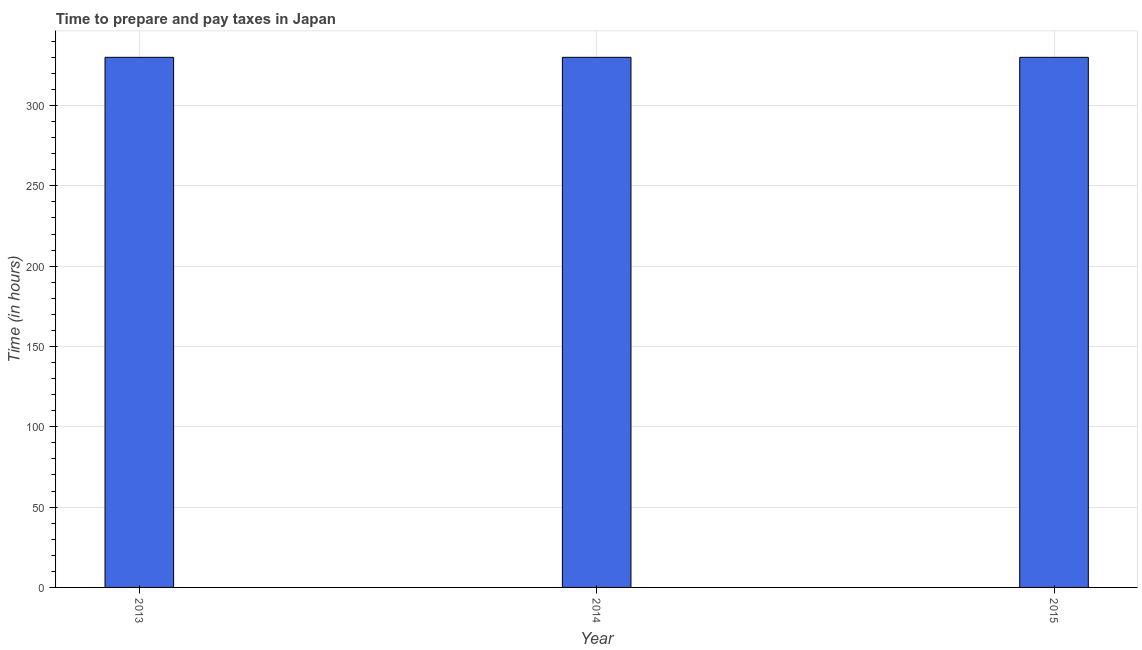Does the graph contain any zero values?
Keep it short and to the point. No. What is the title of the graph?
Offer a very short reply. Time to prepare and pay taxes in Japan. What is the label or title of the X-axis?
Offer a very short reply. Year. What is the label or title of the Y-axis?
Your answer should be very brief. Time (in hours). What is the time to prepare and pay taxes in 2014?
Give a very brief answer. 330. Across all years, what is the maximum time to prepare and pay taxes?
Your answer should be compact. 330. Across all years, what is the minimum time to prepare and pay taxes?
Make the answer very short. 330. In which year was the time to prepare and pay taxes maximum?
Your answer should be compact. 2013. In which year was the time to prepare and pay taxes minimum?
Offer a very short reply. 2013. What is the sum of the time to prepare and pay taxes?
Your answer should be compact. 990. What is the average time to prepare and pay taxes per year?
Your answer should be compact. 330. What is the median time to prepare and pay taxes?
Your answer should be compact. 330. Is the time to prepare and pay taxes in 2014 less than that in 2015?
Give a very brief answer. No. What is the difference between the highest and the second highest time to prepare and pay taxes?
Your answer should be compact. 0. Is the sum of the time to prepare and pay taxes in 2013 and 2015 greater than the maximum time to prepare and pay taxes across all years?
Keep it short and to the point. Yes. What is the difference between the highest and the lowest time to prepare and pay taxes?
Keep it short and to the point. 0. Are all the bars in the graph horizontal?
Your answer should be very brief. No. How many years are there in the graph?
Keep it short and to the point. 3. What is the difference between two consecutive major ticks on the Y-axis?
Ensure brevity in your answer.  50. Are the values on the major ticks of Y-axis written in scientific E-notation?
Your response must be concise. No. What is the Time (in hours) in 2013?
Give a very brief answer. 330. What is the Time (in hours) of 2014?
Offer a terse response. 330. What is the Time (in hours) of 2015?
Your answer should be very brief. 330. What is the difference between the Time (in hours) in 2013 and 2014?
Your answer should be very brief. 0. What is the difference between the Time (in hours) in 2013 and 2015?
Make the answer very short. 0. What is the ratio of the Time (in hours) in 2013 to that in 2014?
Give a very brief answer. 1. What is the ratio of the Time (in hours) in 2014 to that in 2015?
Ensure brevity in your answer.  1. 